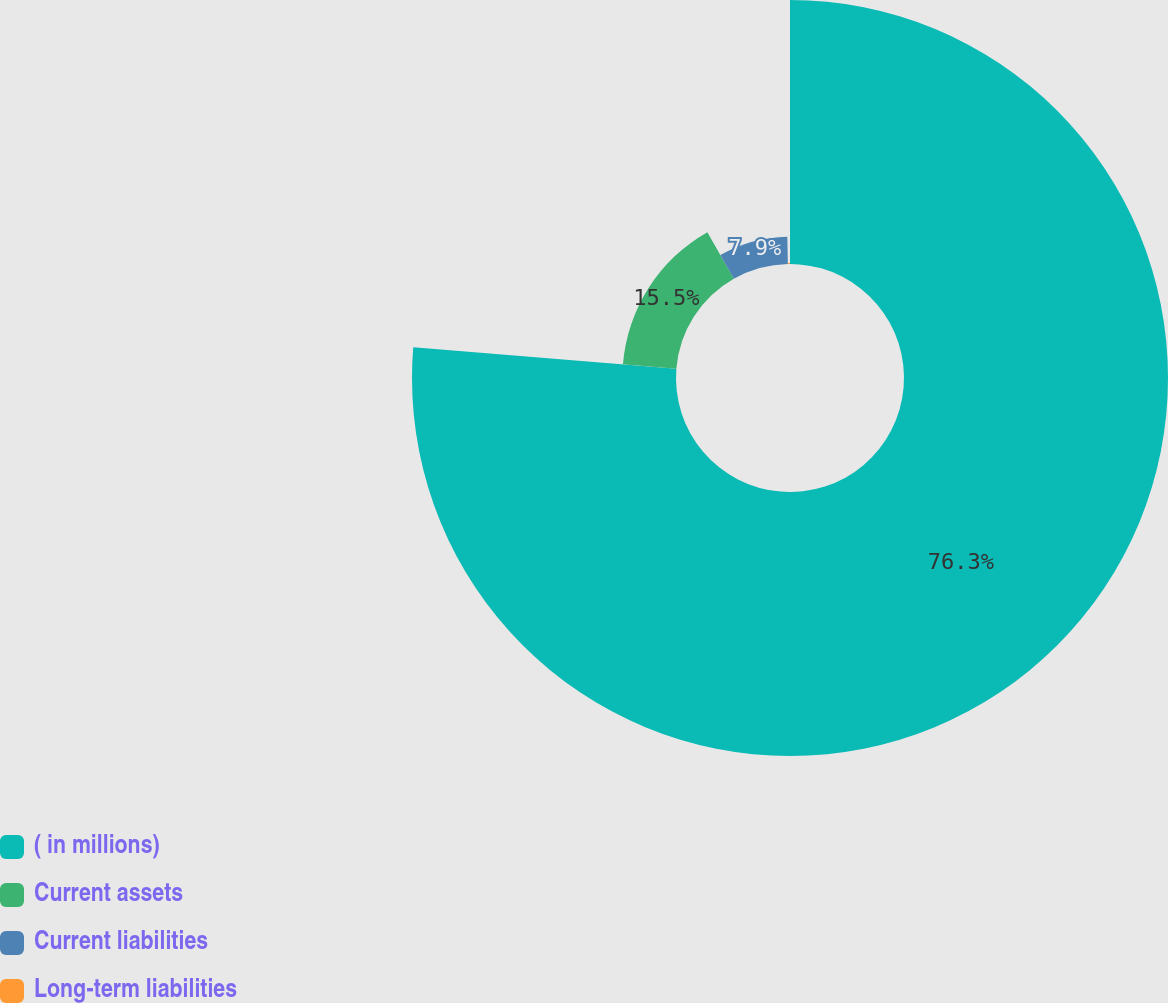<chart> <loc_0><loc_0><loc_500><loc_500><pie_chart><fcel>( in millions)<fcel>Current assets<fcel>Current liabilities<fcel>Long-term liabilities<nl><fcel>76.29%<fcel>15.5%<fcel>7.9%<fcel>0.3%<nl></chart> 